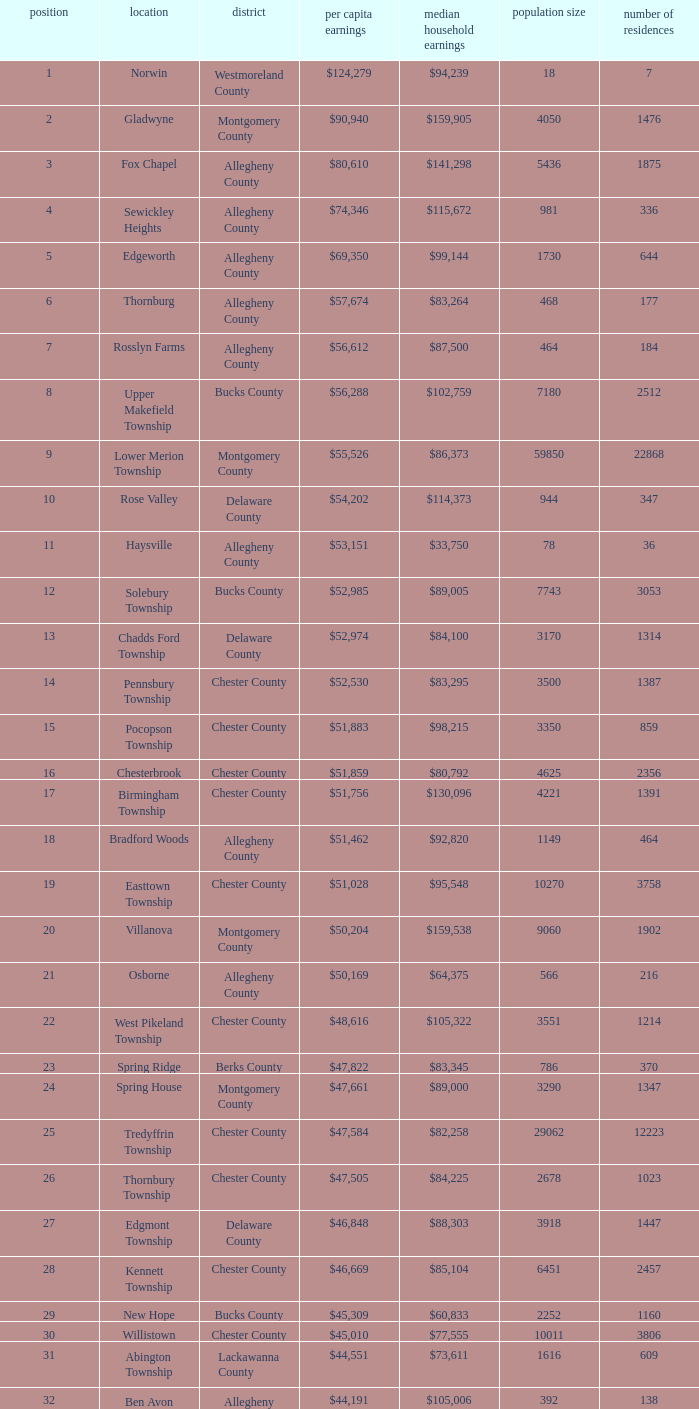Which place has a rank of 71? Wyomissing. 